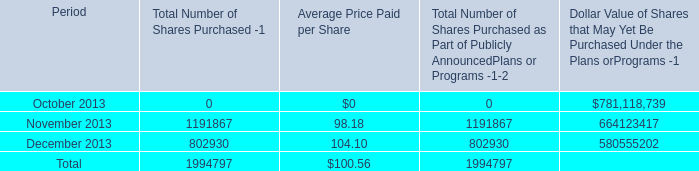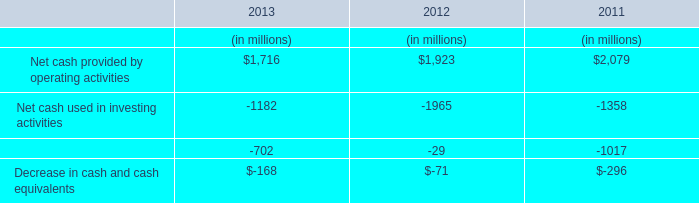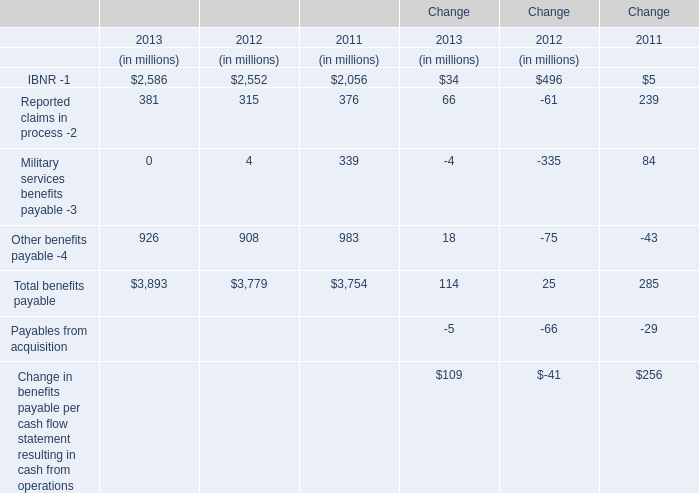what is the percentual increase observed in the average price paid per share during november and december of 2013? 
Computations: ((104.10 / 98.18) - 1)
Answer: 0.0603. 